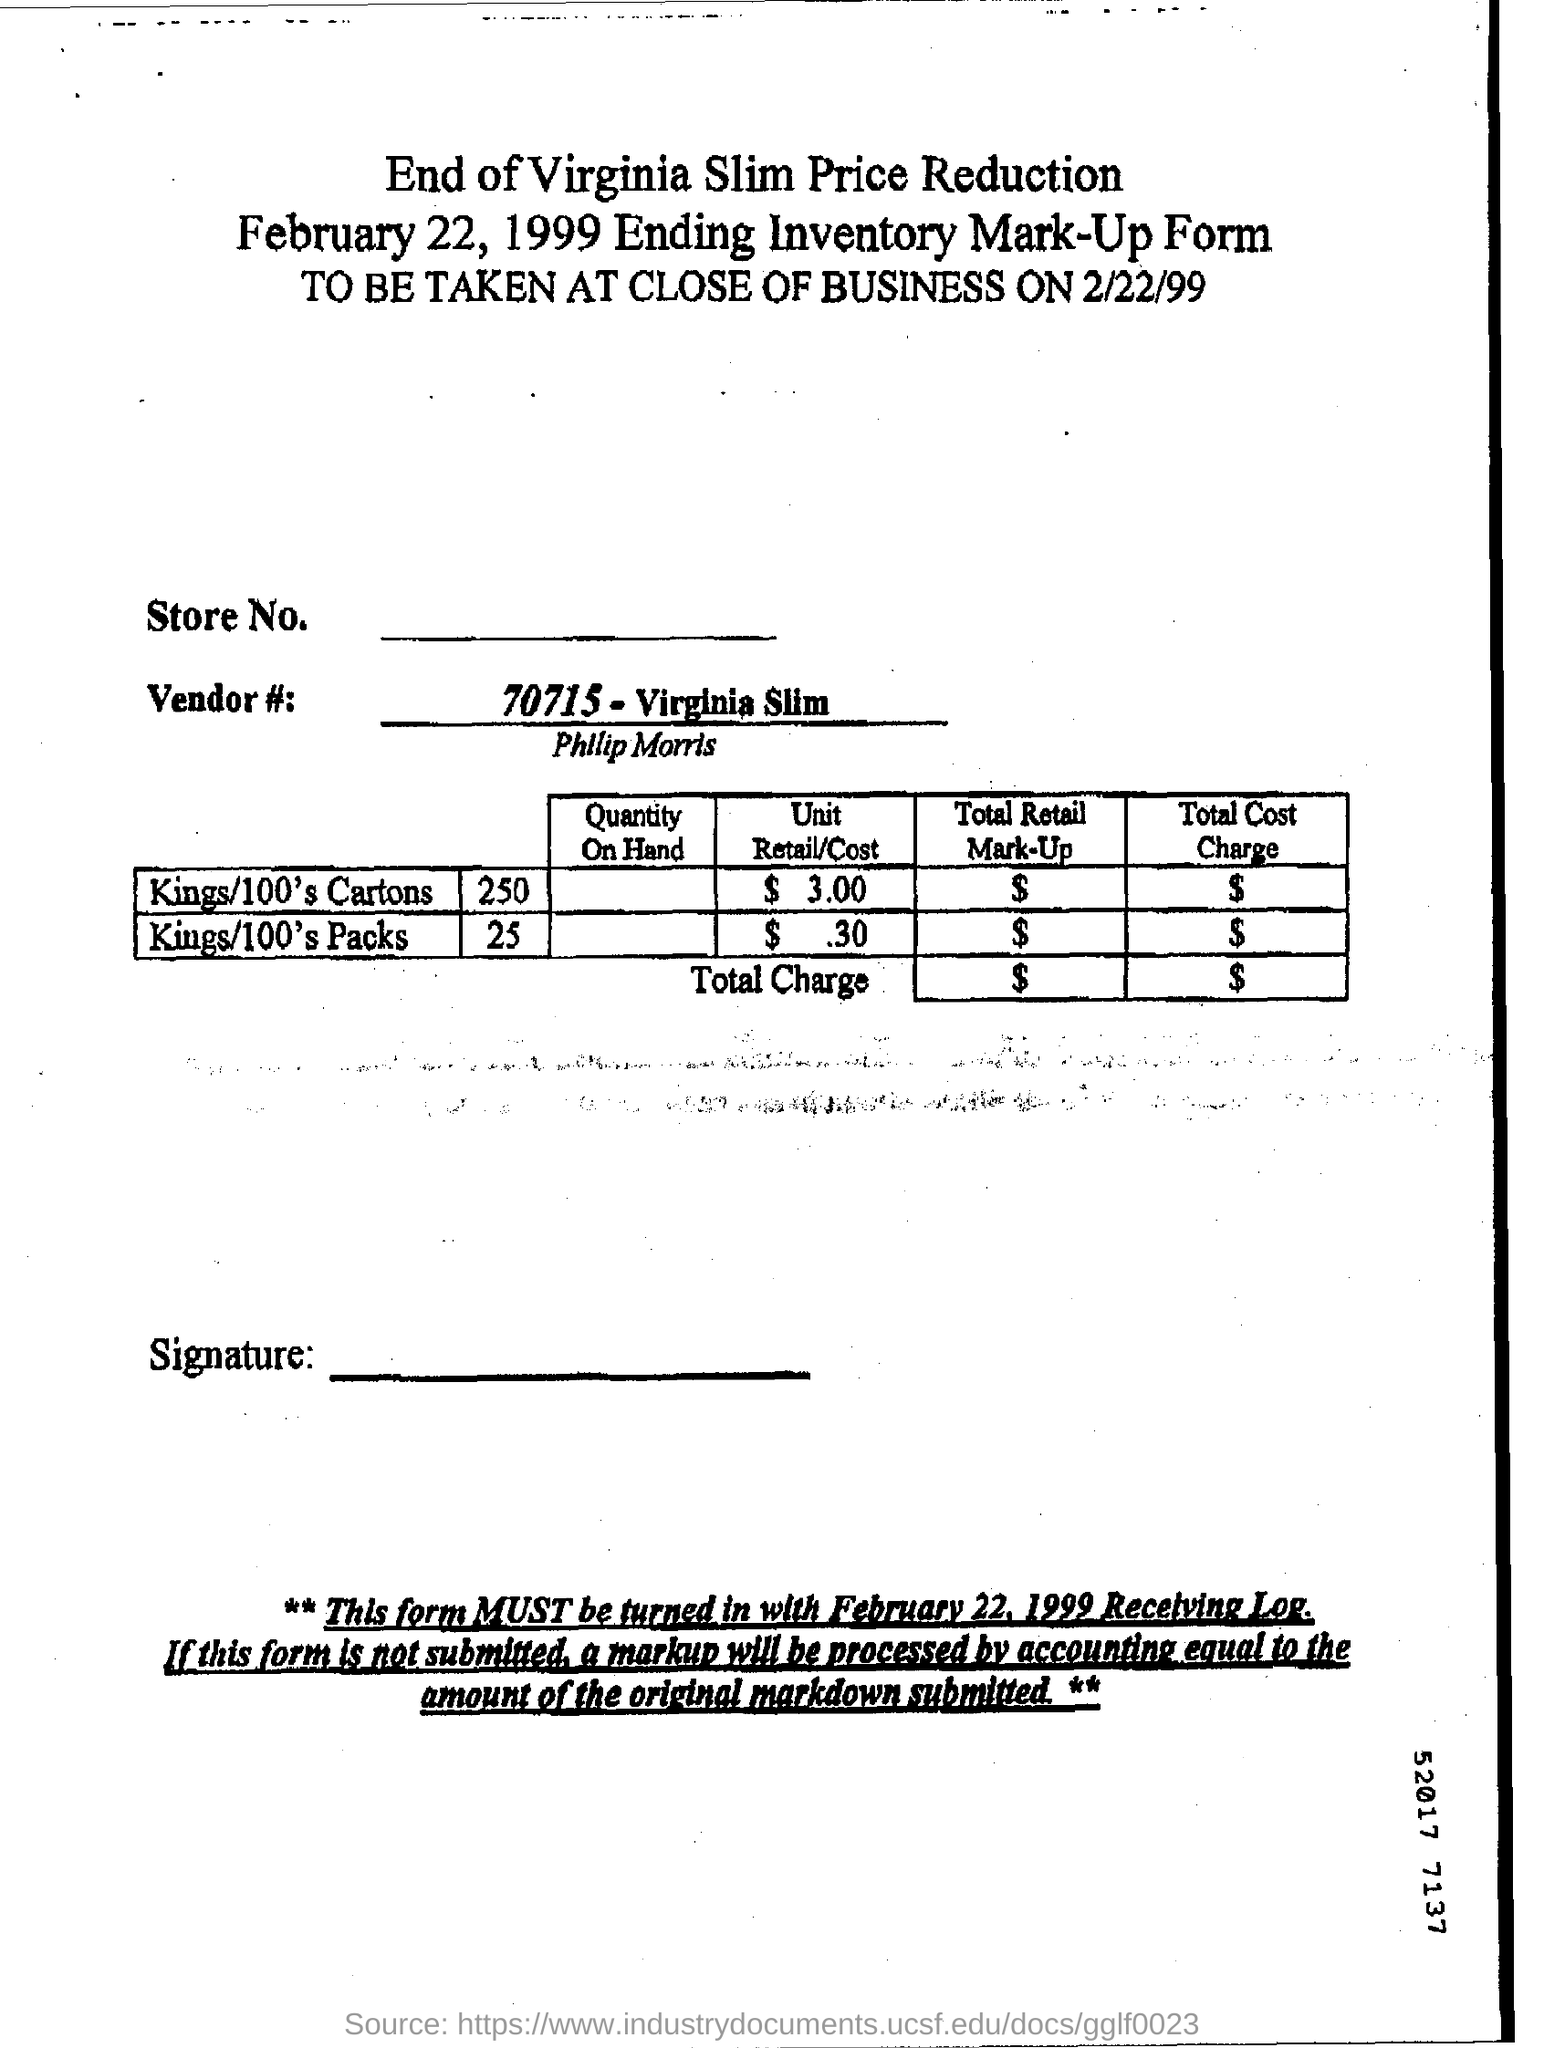Point out several critical features in this image. The vendor number is 70715, and it is associated with the brand Virginia Slim. The title mentions a cigarette brand named Virginia Slim. 